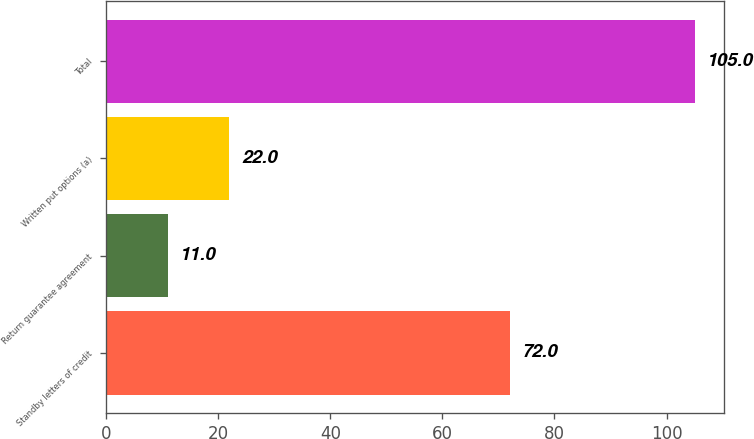Convert chart to OTSL. <chart><loc_0><loc_0><loc_500><loc_500><bar_chart><fcel>Standby letters of credit<fcel>Return guarantee agreement<fcel>Written put options (a)<fcel>Total<nl><fcel>72<fcel>11<fcel>22<fcel>105<nl></chart> 